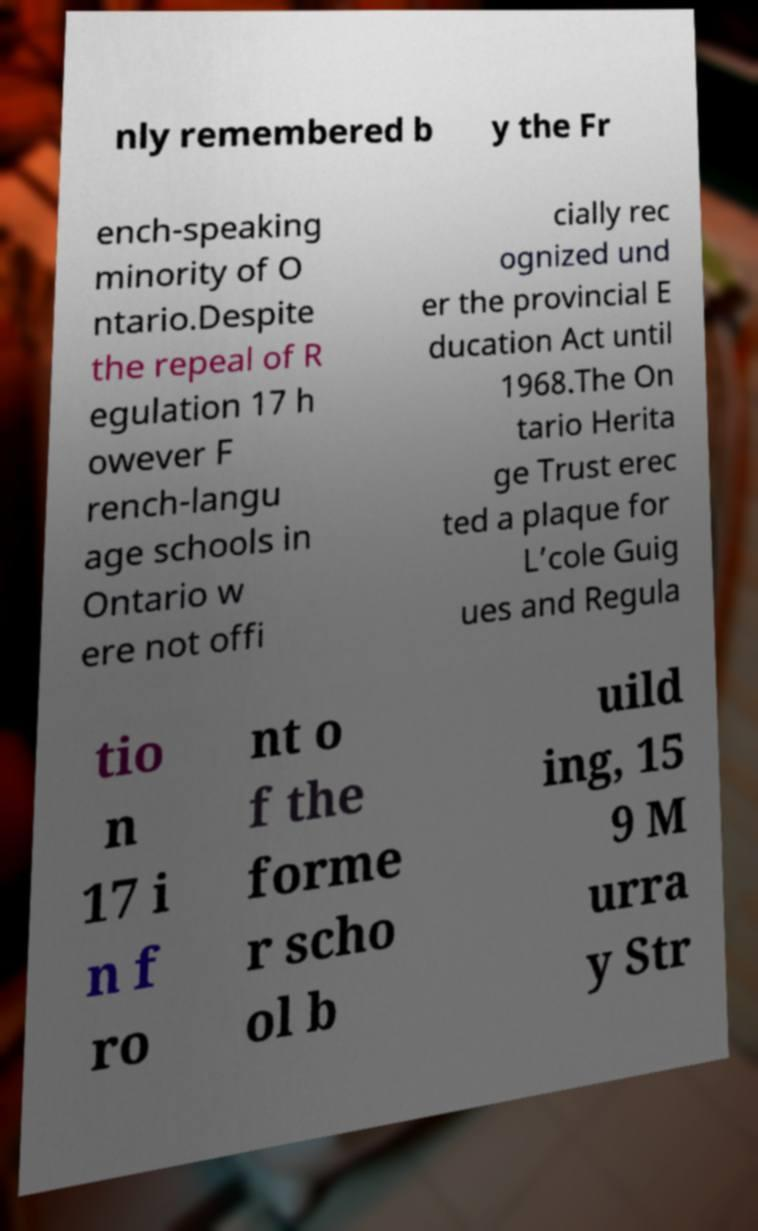Could you extract and type out the text from this image? nly remembered b y the Fr ench-speaking minority of O ntario.Despite the repeal of R egulation 17 h owever F rench-langu age schools in Ontario w ere not offi cially rec ognized und er the provincial E ducation Act until 1968.The On tario Herita ge Trust erec ted a plaque for L’cole Guig ues and Regula tio n 17 i n f ro nt o f the forme r scho ol b uild ing, 15 9 M urra y Str 